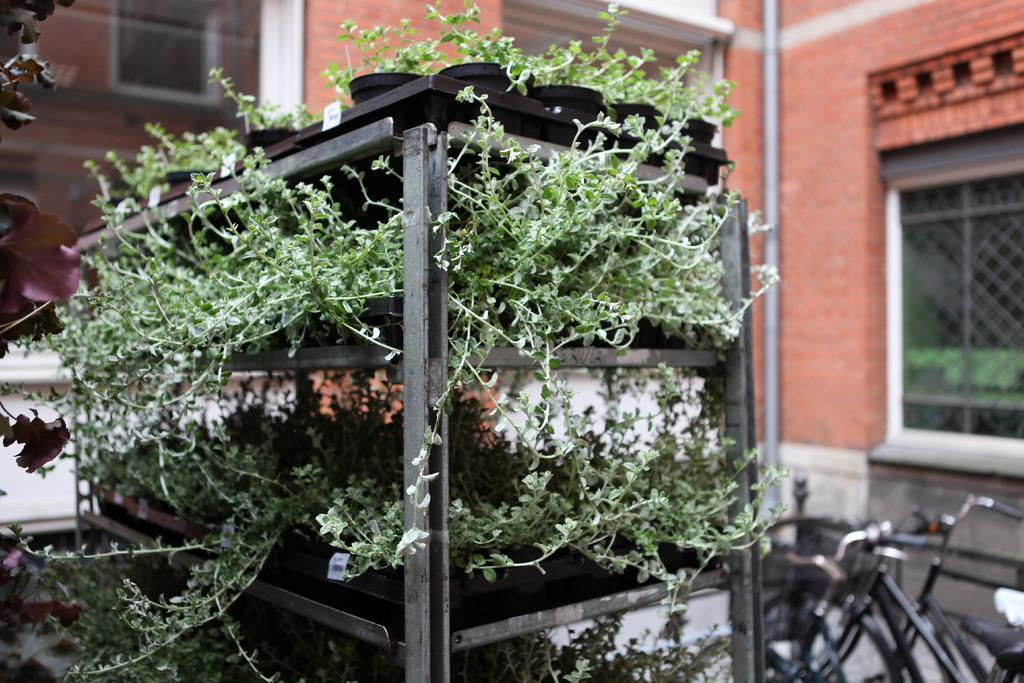Could you give a brief overview of what you see in this image? In this image we can see plants potted in the trays and placed in the cupboard. In the background there are buildings, windows, pipelines and bicycles on the floor. 